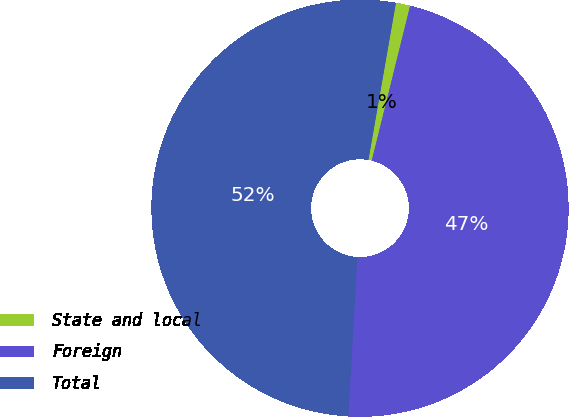Convert chart to OTSL. <chart><loc_0><loc_0><loc_500><loc_500><pie_chart><fcel>State and local<fcel>Foreign<fcel>Total<nl><fcel>1.11%<fcel>47.03%<fcel>51.86%<nl></chart> 